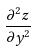<formula> <loc_0><loc_0><loc_500><loc_500>\frac { \partial ^ { 2 } z } { \partial y ^ { 2 } }</formula> 